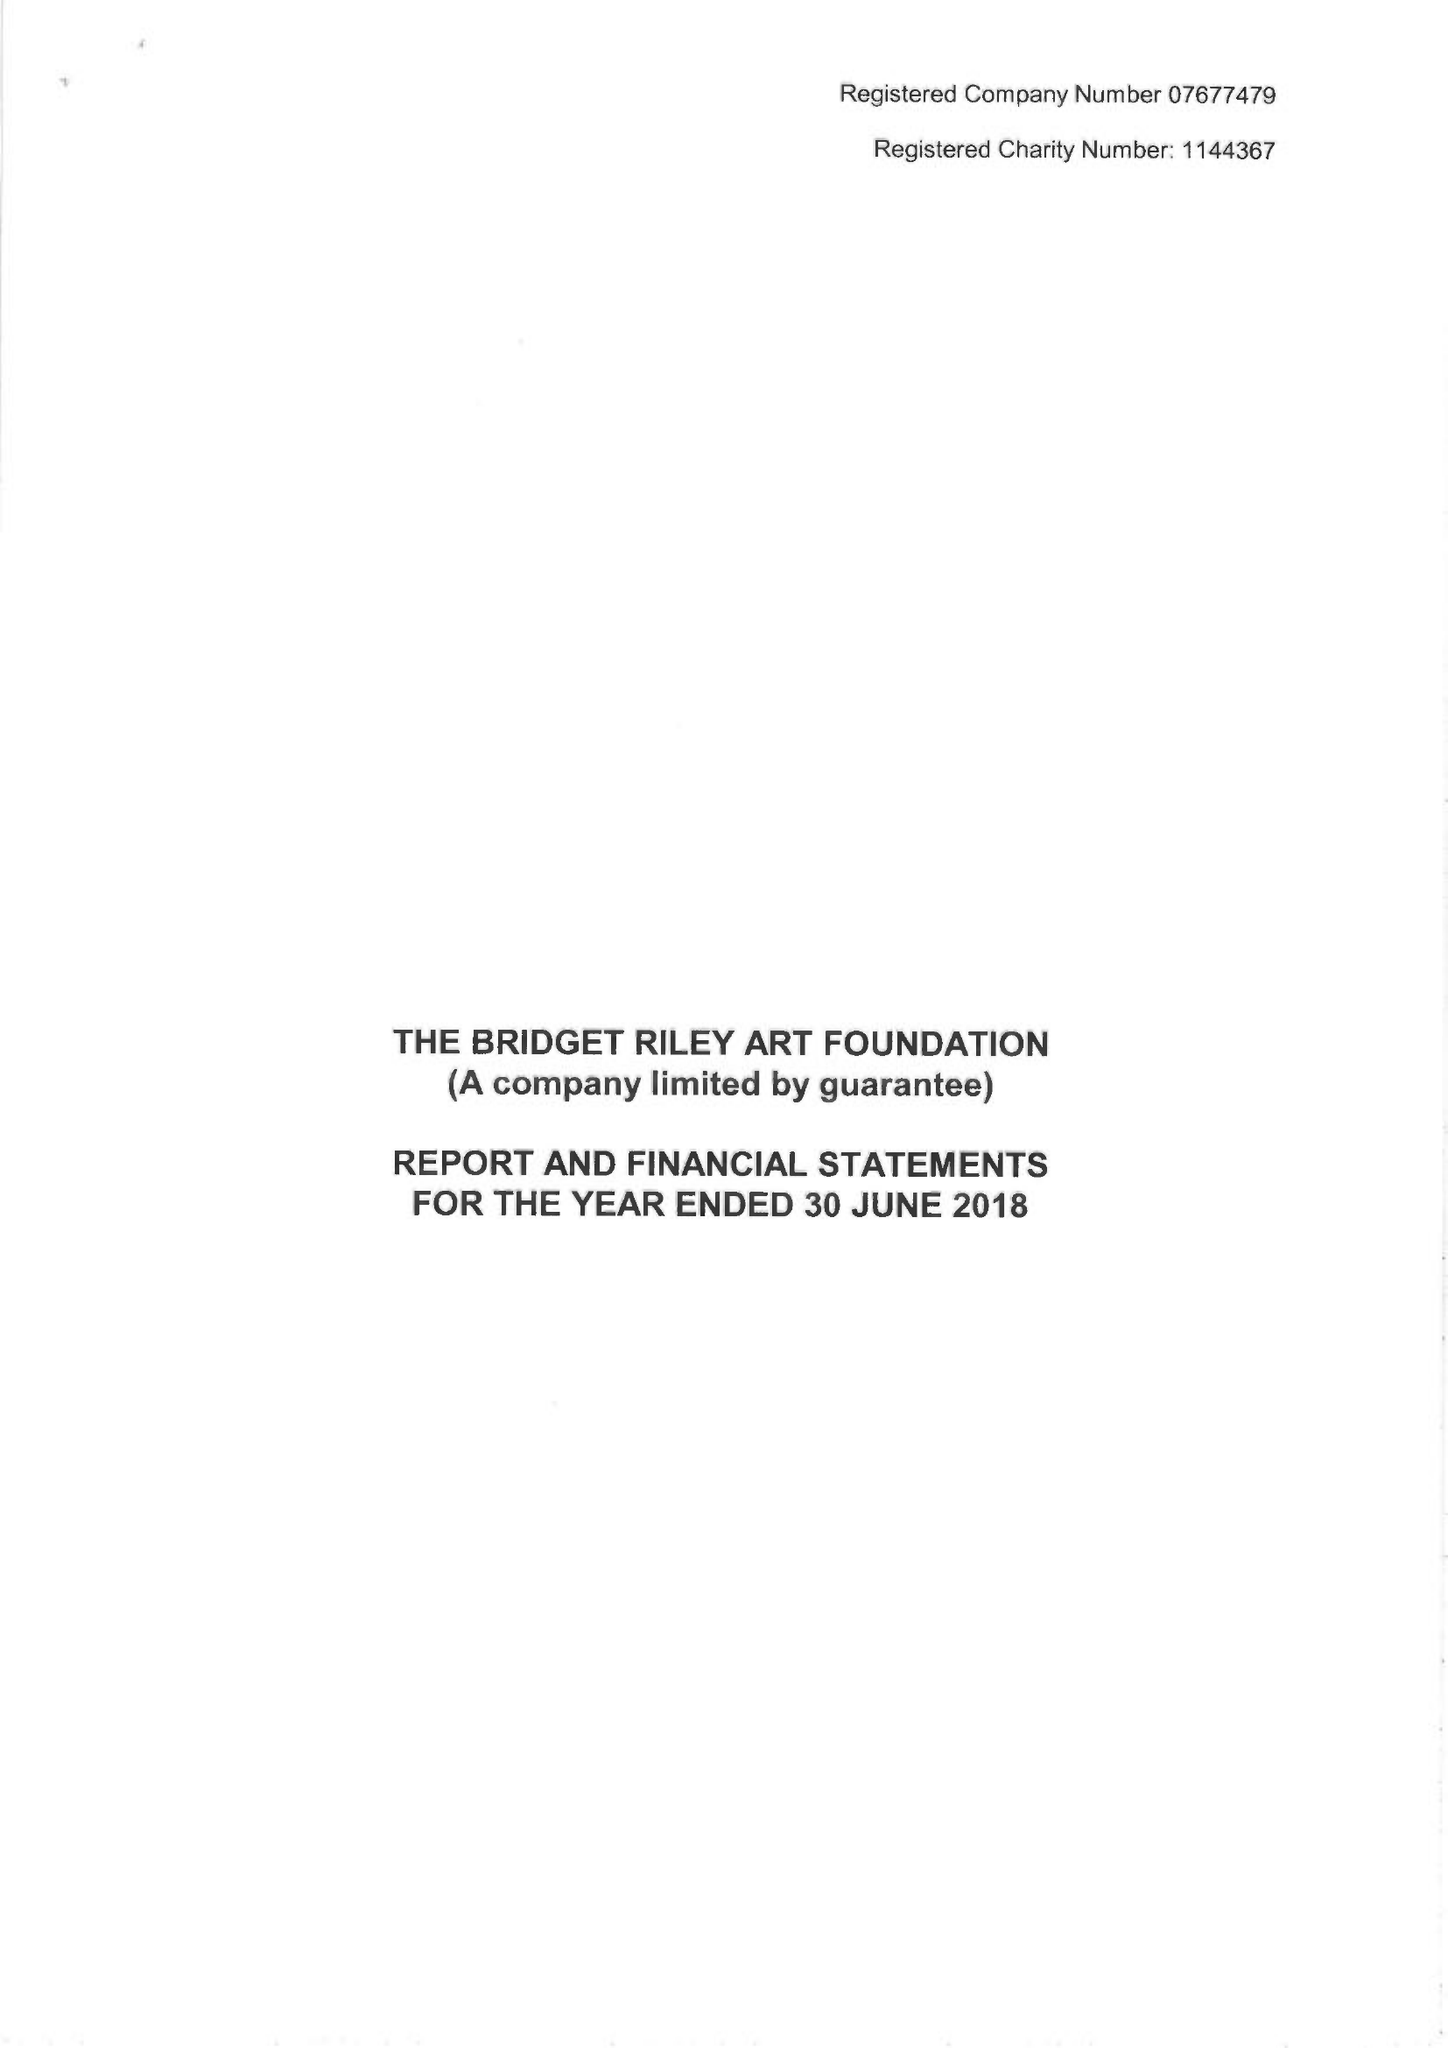What is the value for the address__postcode?
Answer the question using a single word or phrase. W11 4SL 